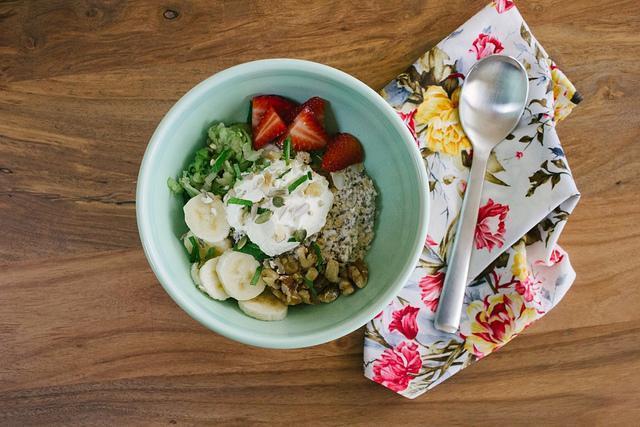How many spoons are visible?
Give a very brief answer. 1. How many people are pulling luggage?
Give a very brief answer. 0. 